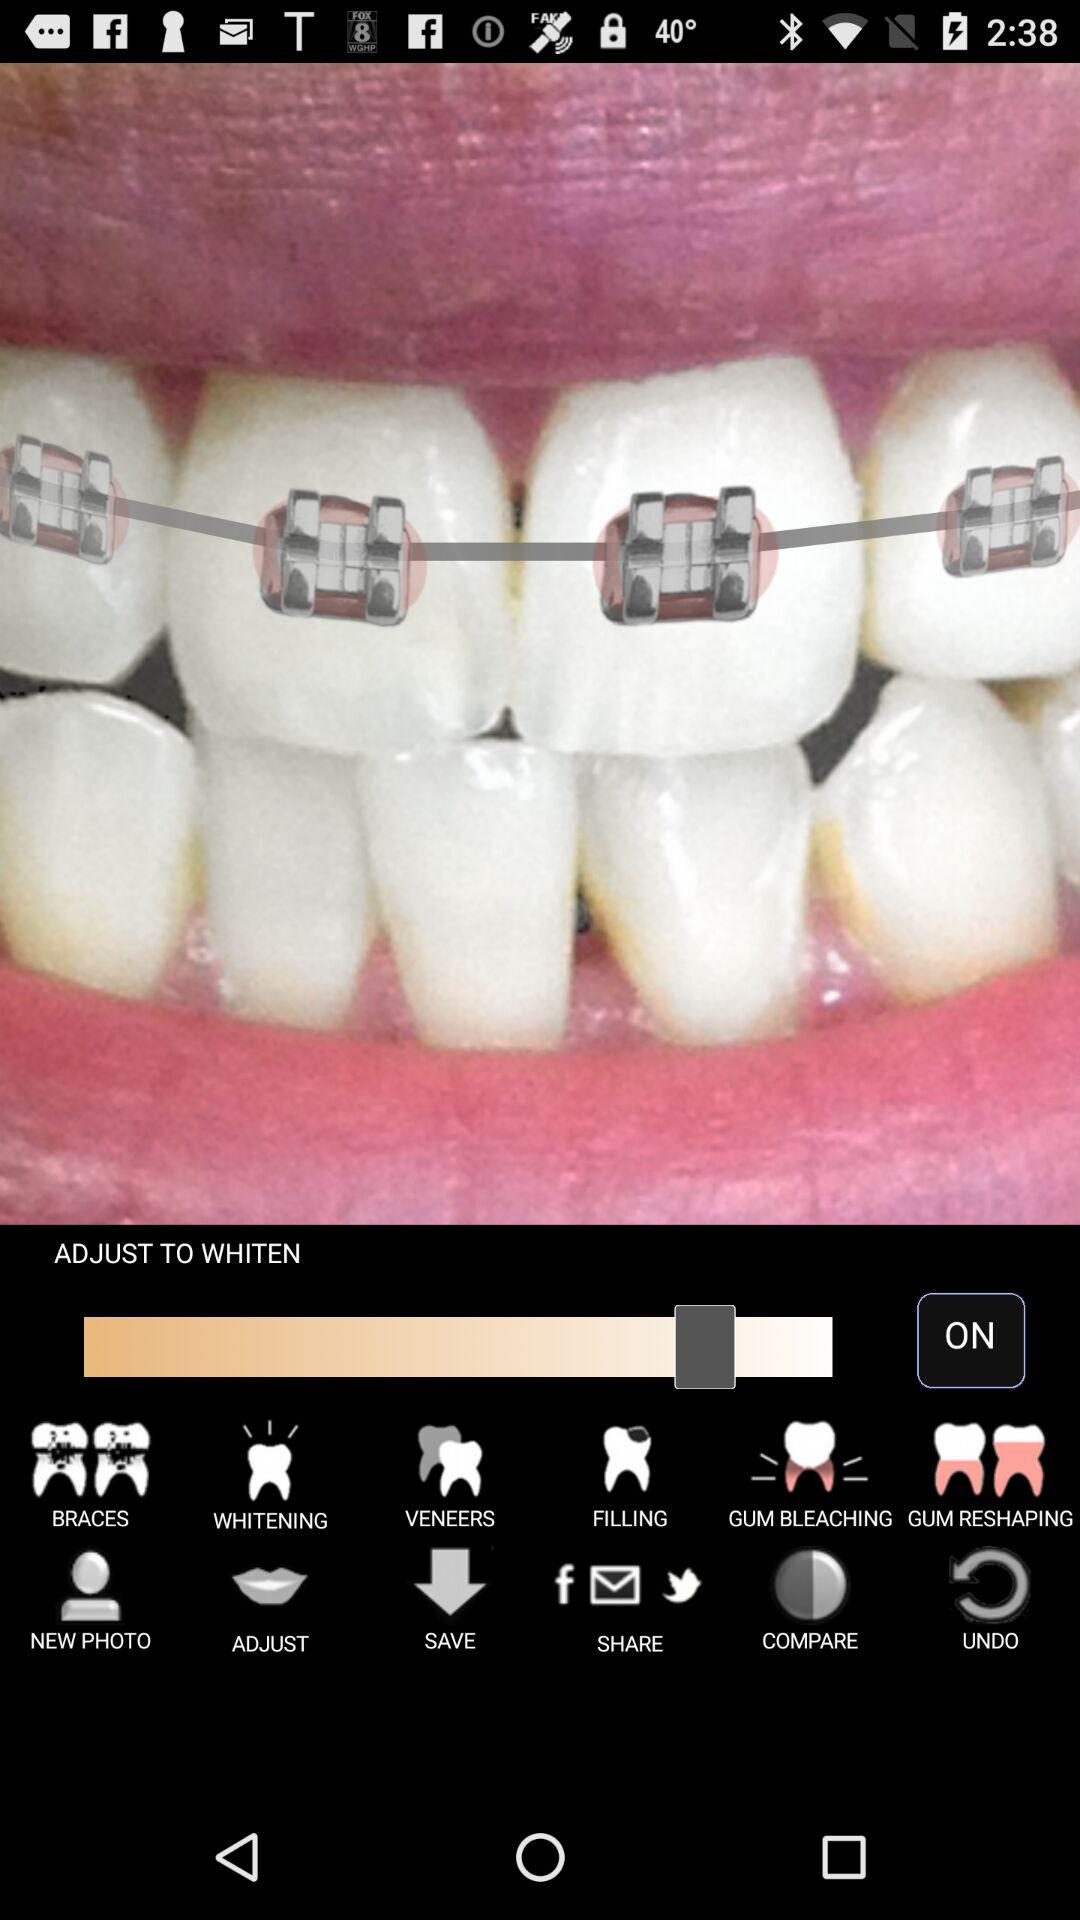What's the status of "ADJUST TO WHITEN"? The status is "on". 